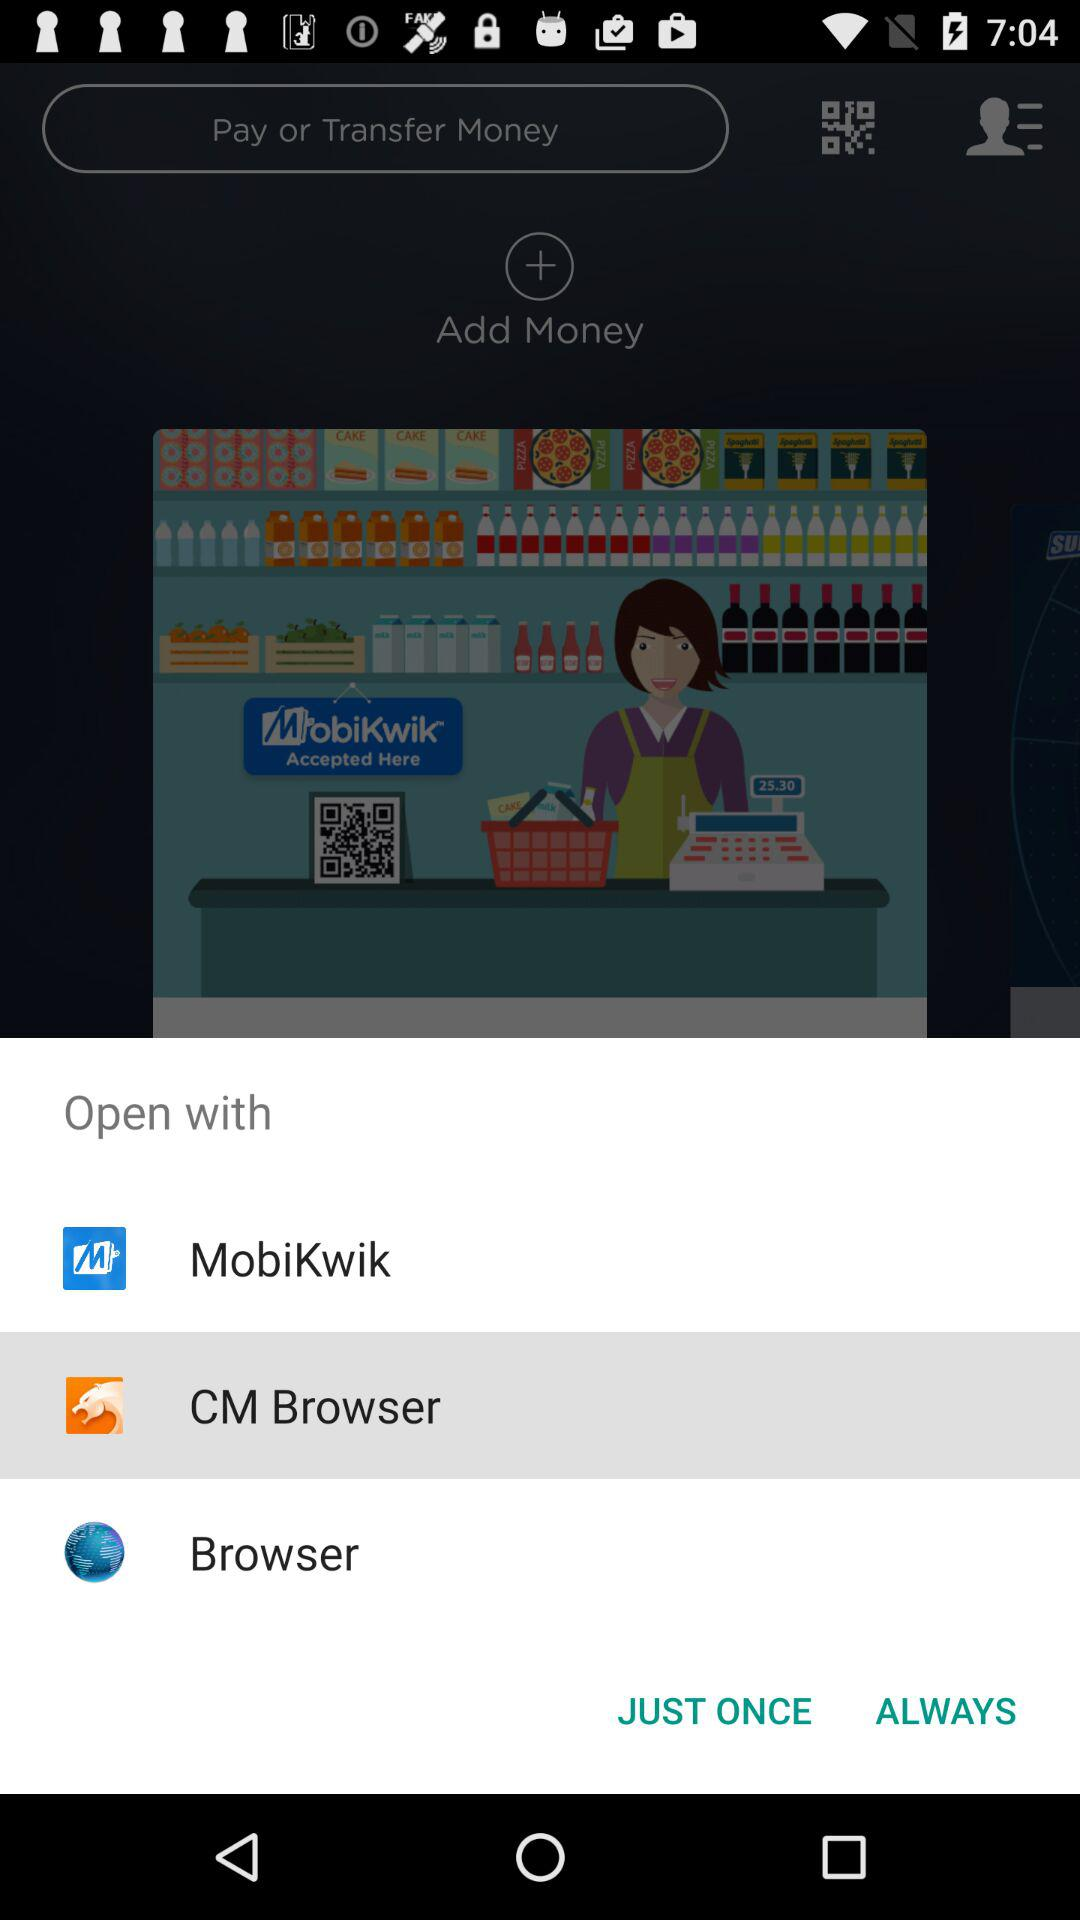Which option is selected? The selected option is "CM Browser". 